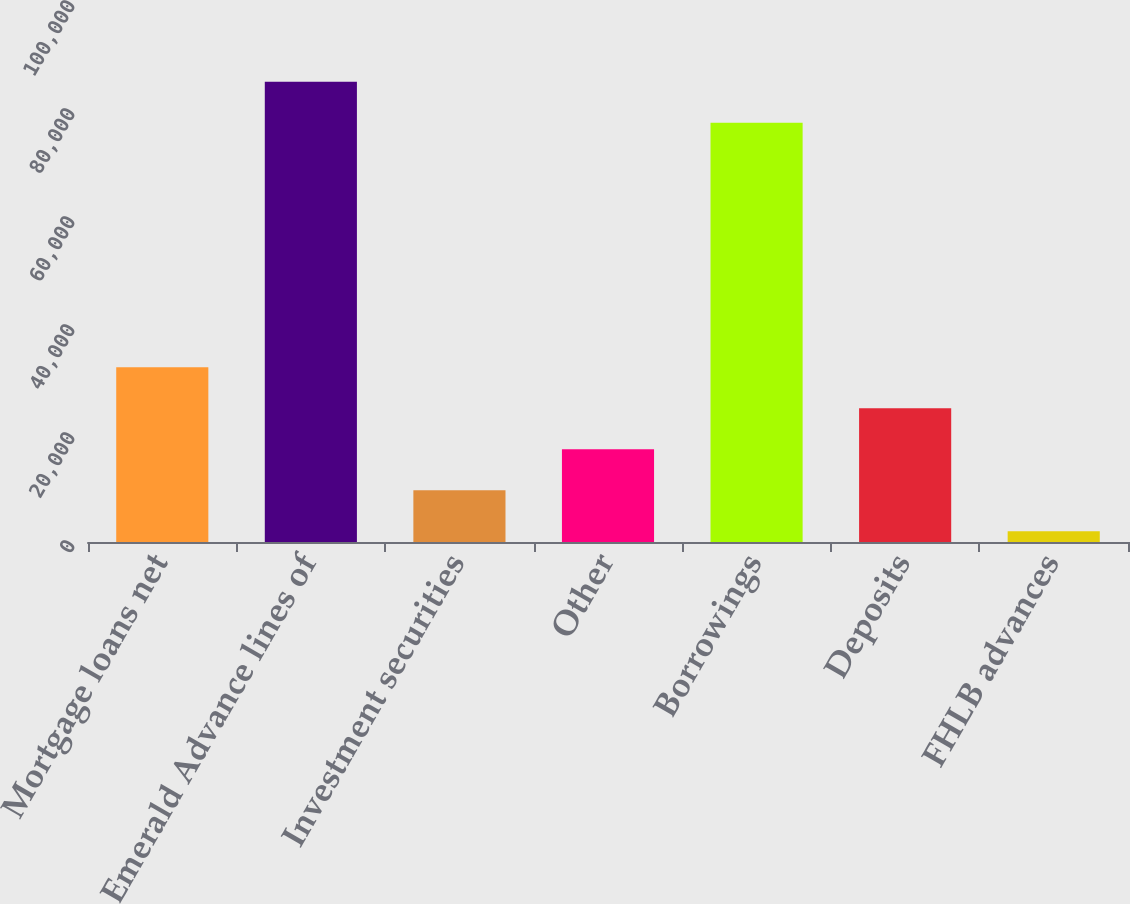Convert chart. <chart><loc_0><loc_0><loc_500><loc_500><bar_chart><fcel>Mortgage loans net<fcel>Emerald Advance lines of<fcel>Investment securities<fcel>Other<fcel>Borrowings<fcel>Deposits<fcel>FHLB advances<nl><fcel>32354.6<fcel>85248.4<fcel>9586.4<fcel>17175.8<fcel>77659<fcel>24765.2<fcel>1997<nl></chart> 